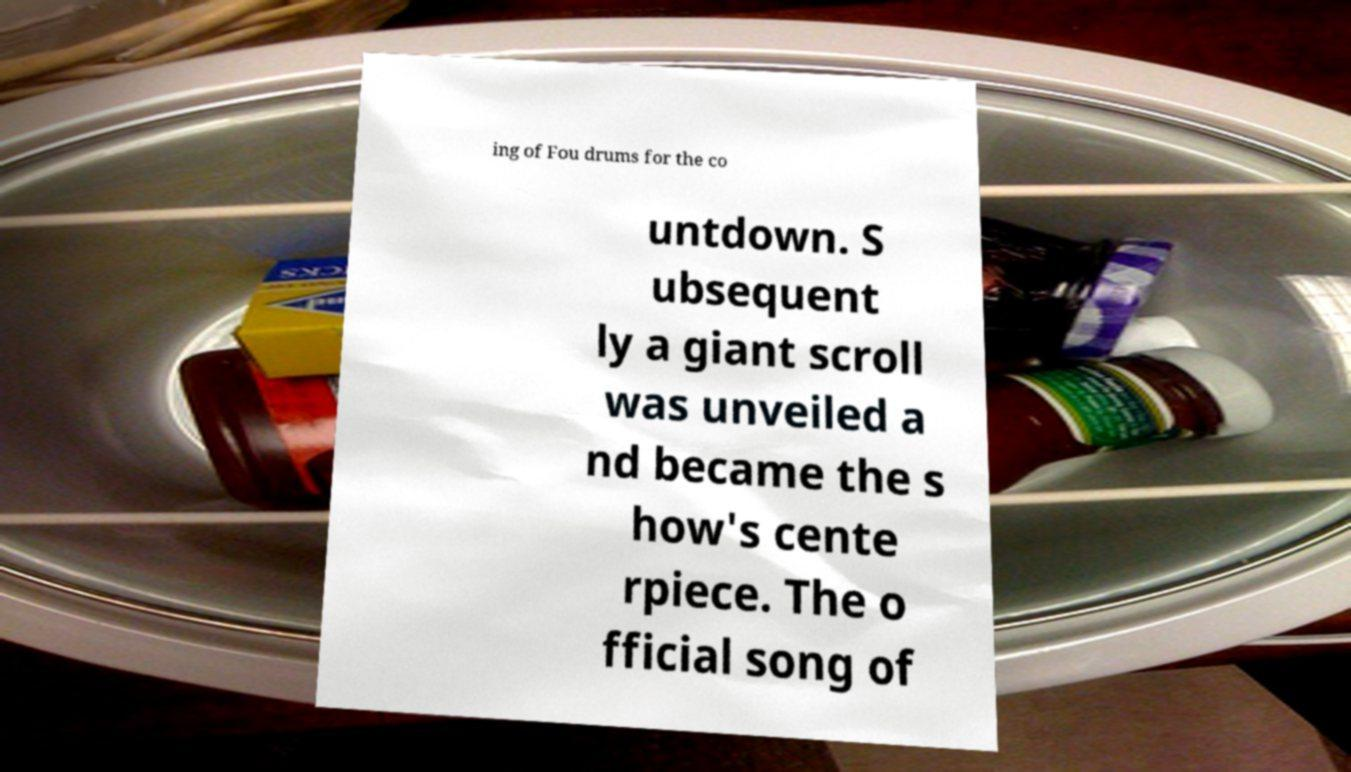For documentation purposes, I need the text within this image transcribed. Could you provide that? ing of Fou drums for the co untdown. S ubsequent ly a giant scroll was unveiled a nd became the s how's cente rpiece. The o fficial song of 